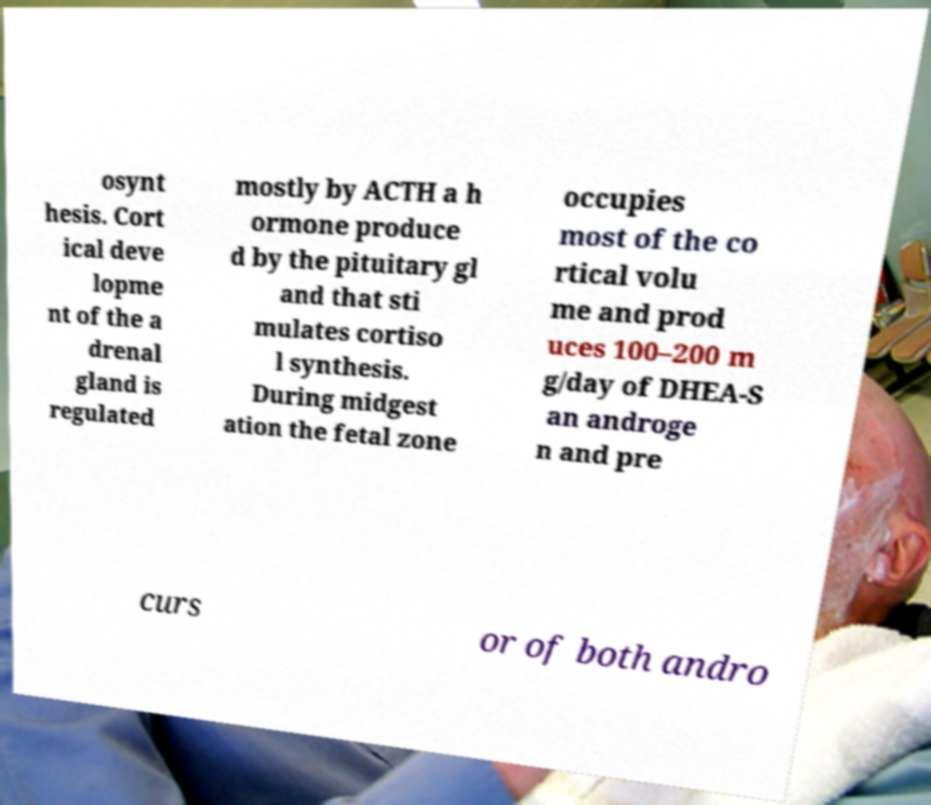Please read and relay the text visible in this image. What does it say? osynt hesis. Cort ical deve lopme nt of the a drenal gland is regulated mostly by ACTH a h ormone produce d by the pituitary gl and that sti mulates cortiso l synthesis. During midgest ation the fetal zone occupies most of the co rtical volu me and prod uces 100–200 m g/day of DHEA-S an androge n and pre curs or of both andro 